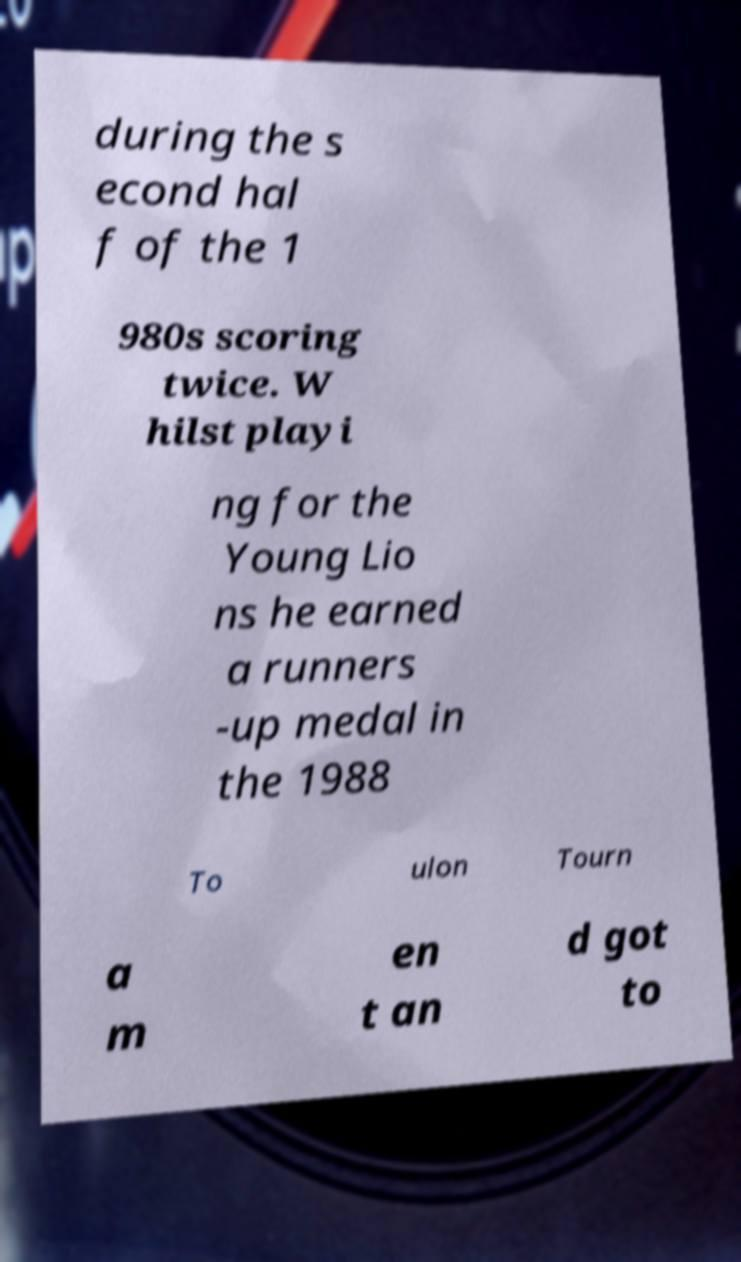Could you assist in decoding the text presented in this image and type it out clearly? during the s econd hal f of the 1 980s scoring twice. W hilst playi ng for the Young Lio ns he earned a runners -up medal in the 1988 To ulon Tourn a m en t an d got to 